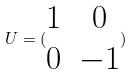Convert formula to latex. <formula><loc_0><loc_0><loc_500><loc_500>U = ( \begin{matrix} 1 & 0 \\ 0 & - 1 \end{matrix} )</formula> 